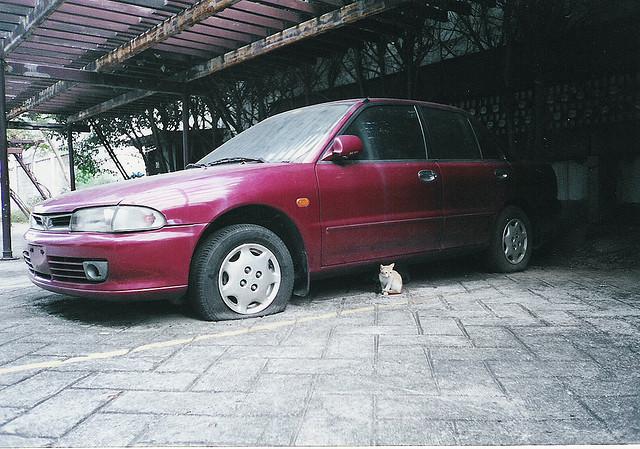Is this car expensive today?
Short answer required. No. Does the car have a flat tire?
Quick response, please. Yes. What is beneath the car?
Quick response, please. Cat. 